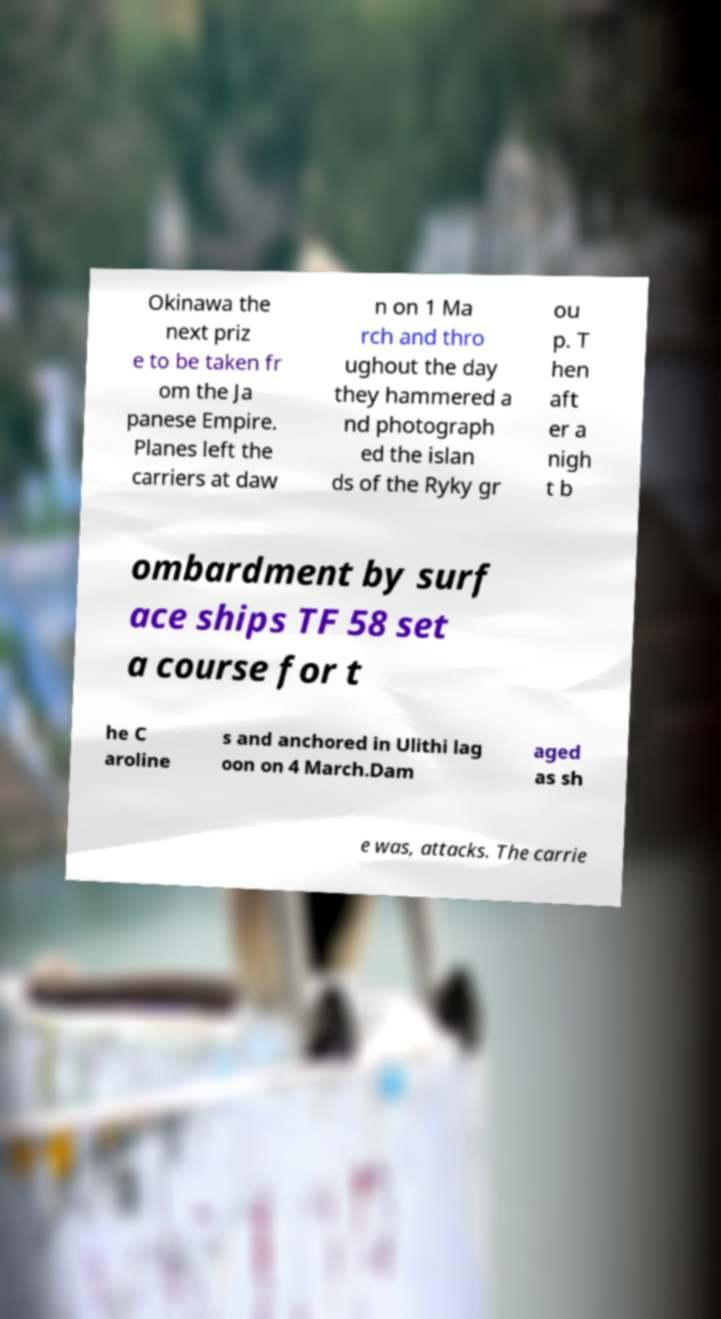There's text embedded in this image that I need extracted. Can you transcribe it verbatim? Okinawa the next priz e to be taken fr om the Ja panese Empire. Planes left the carriers at daw n on 1 Ma rch and thro ughout the day they hammered a nd photograph ed the islan ds of the Ryky gr ou p. T hen aft er a nigh t b ombardment by surf ace ships TF 58 set a course for t he C aroline s and anchored in Ulithi lag oon on 4 March.Dam aged as sh e was, attacks. The carrie 